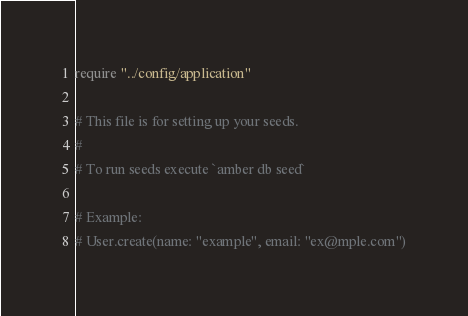Convert code to text. <code><loc_0><loc_0><loc_500><loc_500><_Crystal_>require "../config/application"

# This file is for setting up your seeds.
#
# To run seeds execute `amber db seed`

# Example:
# User.create(name: "example", email: "ex@mple.com")
</code> 